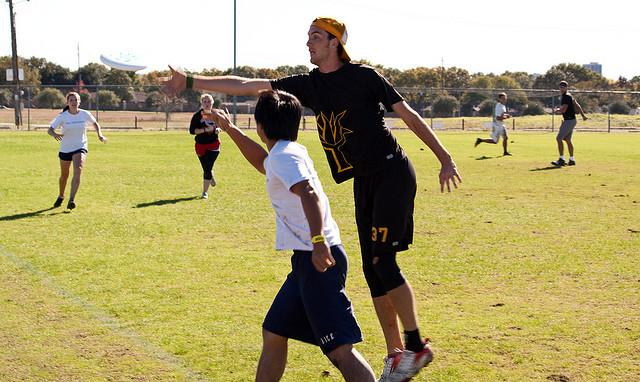What sport are the people playing? frisbee 